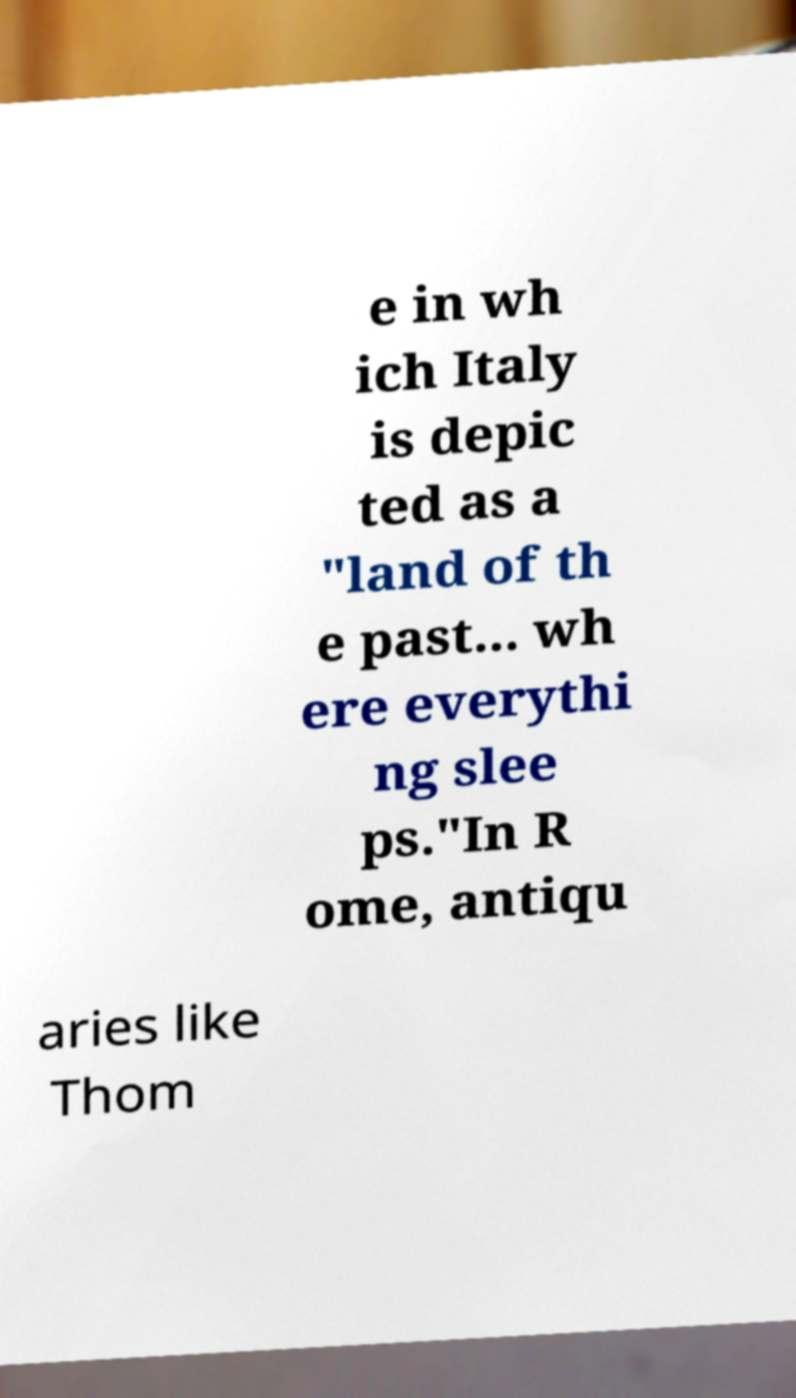Can you accurately transcribe the text from the provided image for me? e in wh ich Italy is depic ted as a "land of th e past... wh ere everythi ng slee ps."In R ome, antiqu aries like Thom 